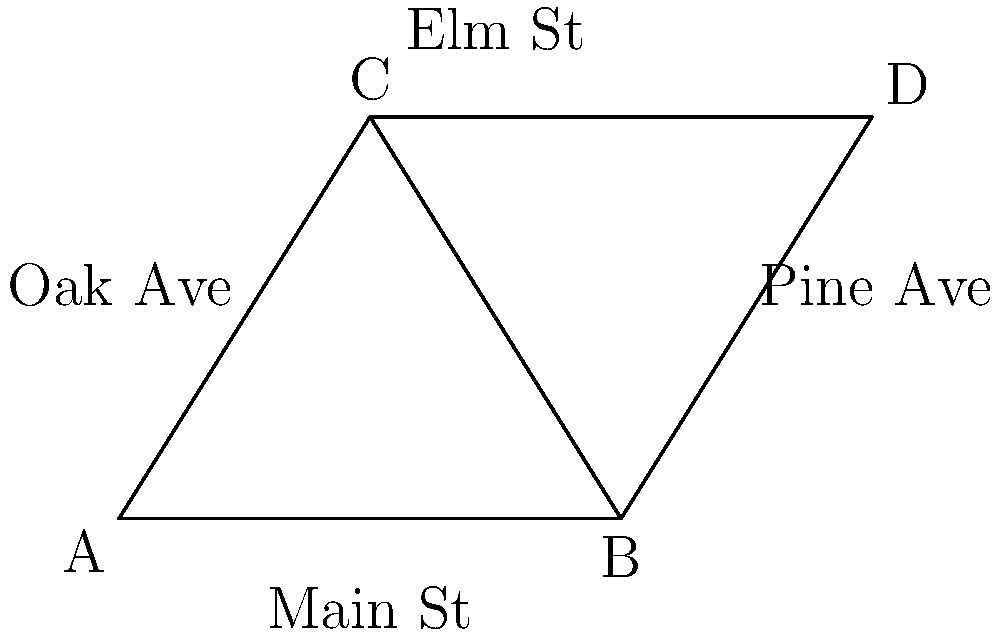In the small town of Meadowville, the main intersection forms two triangles as shown in the diagram. Main Street runs along the base of both triangles, while Elm Street forms the top side. Oak Avenue and Pine Avenue form the other two sides. If triangle ABC is congruent to triangle BCD, what can you conclude about Oak Avenue and Pine Avenue? Let's approach this step-by-step:

1. We are told that triangle ABC is congruent to triangle BCD.

2. Congruent triangles have all corresponding sides and angles equal.

3. In these triangles:
   - Side BC is shared by both triangles
   - AB corresponds to BD (both along Main Street)
   - AC corresponds to CD (both from Main Street to Elm Street)

4. Since the triangles are congruent, we know that:
   - $AB = BD$ (Main Street segments are equal)
   - $AC = CD$ (Oak Avenue and Pine Avenue)

5. The question specifically asks about Oak Avenue (AC) and Pine Avenue (CD).

6. Since AC corresponds to CD in the congruent triangles, and congruent triangles have corresponding sides equal, we can conclude that Oak Avenue and Pine Avenue must be equal in length.
Answer: Oak Avenue and Pine Avenue are equal in length. 